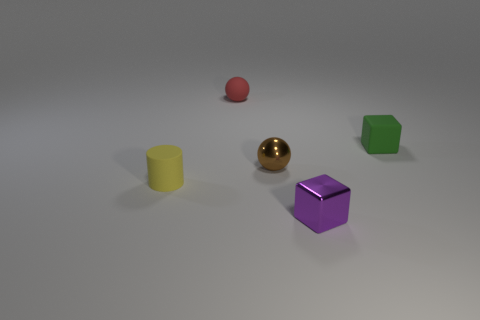Add 4 brown objects. How many objects exist? 9 Subtract all cylinders. How many objects are left? 4 Add 3 blocks. How many blocks are left? 5 Add 4 balls. How many balls exist? 6 Subtract 0 green balls. How many objects are left? 5 Subtract all yellow matte things. Subtract all tiny green things. How many objects are left? 3 